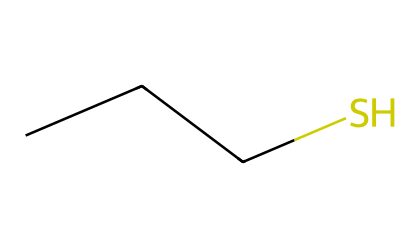What is the main functional group present in this compound? The SMILES representation indicates a sulfur atom (S) bonded to a carbon (C) chain with a hydroxyl group (-SH) at the end, making it a thiol.
Answer: thiol How many carbon atoms are in this molecule? Analyzing the SMILES representation, we see three carbon atoms (C) in the chain CCC, indicating there are a total of three carbon atoms.
Answer: 3 What type of bond connects the sulfur to the carbon chain? The structure shows a single bond between the sulfur atom and the carbon atoms, which is characteristic of thiols.
Answer: single bond What is the molecular formula for this compound? To derive the molecular formula, we count the atoms represented: three carbons (C), eight hydrogens (H), and one sulfur (S), resulting in C3H8S.
Answer: C3H8S What property do thiols possess due to the presence of the sulfur atom? Thiols are known to have strong and often unpleasant odors due to the sulfur atom, giving them unique sensory properties.
Answer: strong odor What is the role of thiols in odor-neutralizing sprays? Thiols can neutralize unpleasant odors due to their ability to bind to odor-causing molecules, effectively masking or eliminating them.
Answer: neutralizing odors 